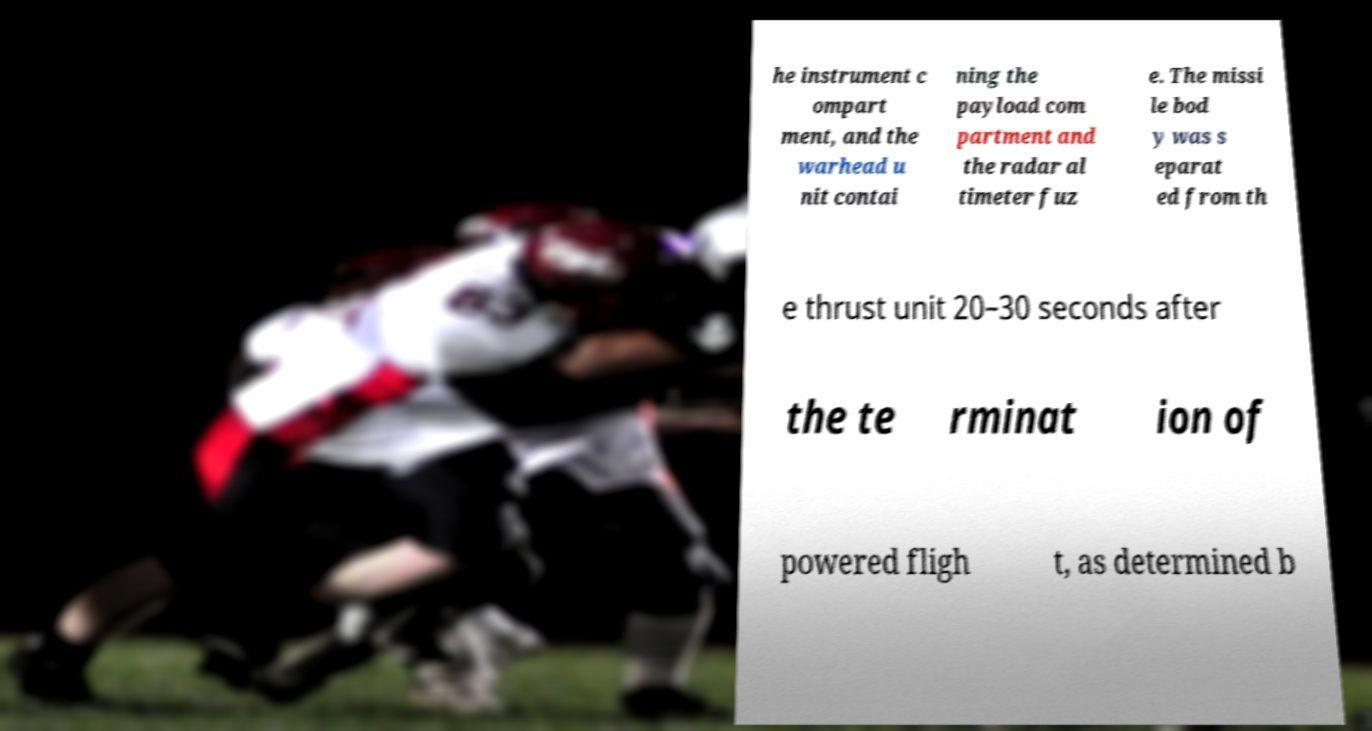I need the written content from this picture converted into text. Can you do that? he instrument c ompart ment, and the warhead u nit contai ning the payload com partment and the radar al timeter fuz e. The missi le bod y was s eparat ed from th e thrust unit 20–30 seconds after the te rminat ion of powered fligh t, as determined b 